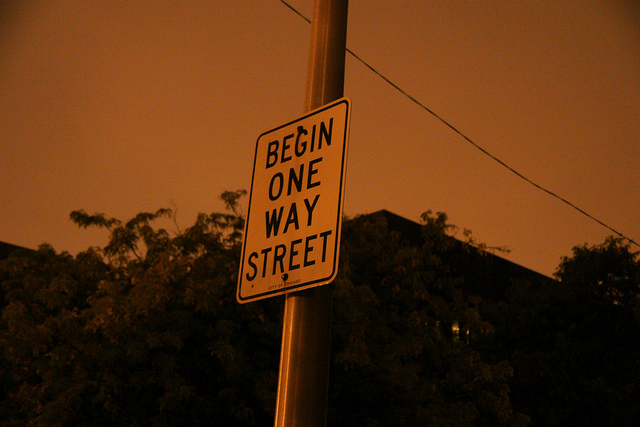Please transcribe the text in this image. BEGIN ONE WAY STREET 